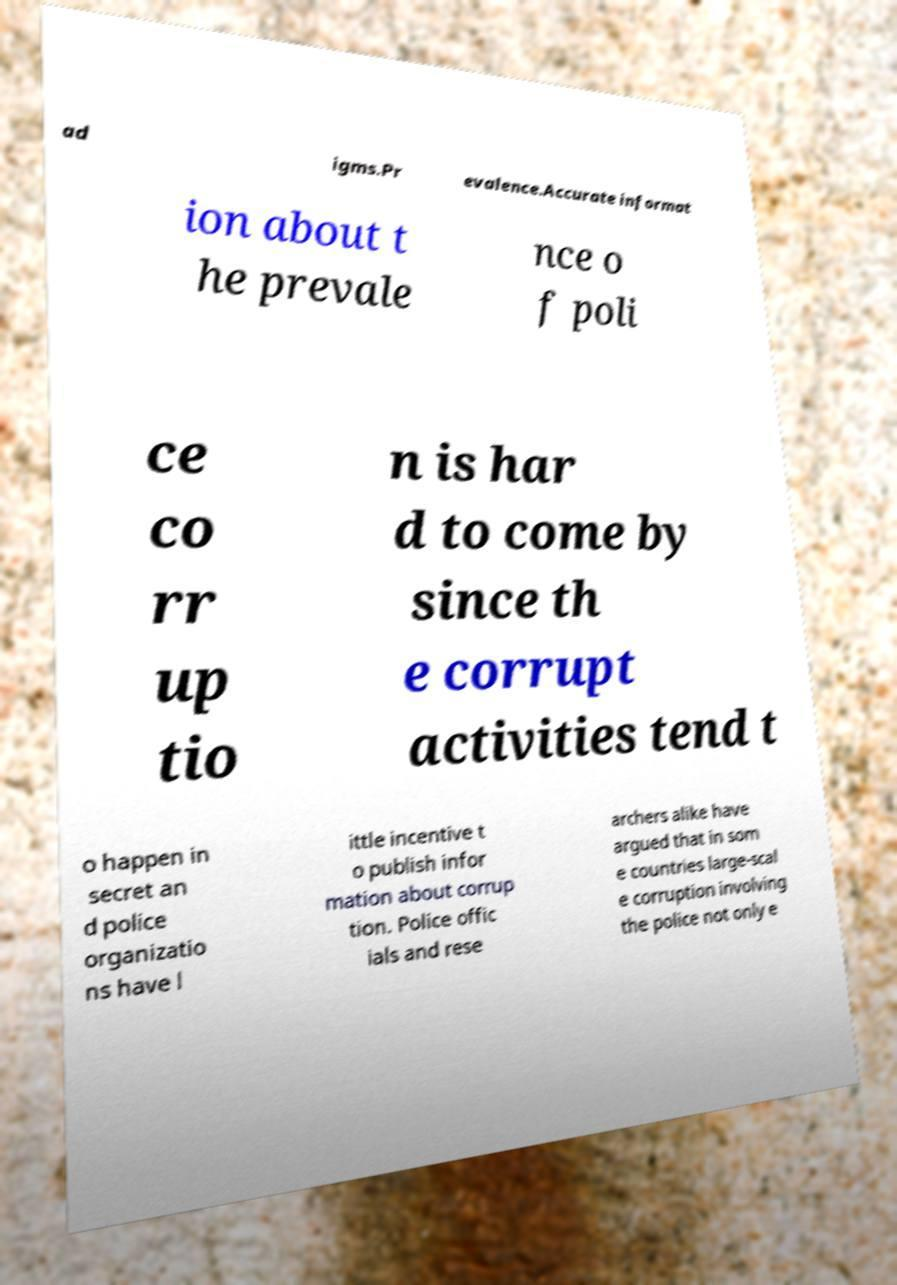Can you read and provide the text displayed in the image?This photo seems to have some interesting text. Can you extract and type it out for me? ad igms.Pr evalence.Accurate informat ion about t he prevale nce o f poli ce co rr up tio n is har d to come by since th e corrupt activities tend t o happen in secret an d police organizatio ns have l ittle incentive t o publish infor mation about corrup tion. Police offic ials and rese archers alike have argued that in som e countries large-scal e corruption involving the police not only e 